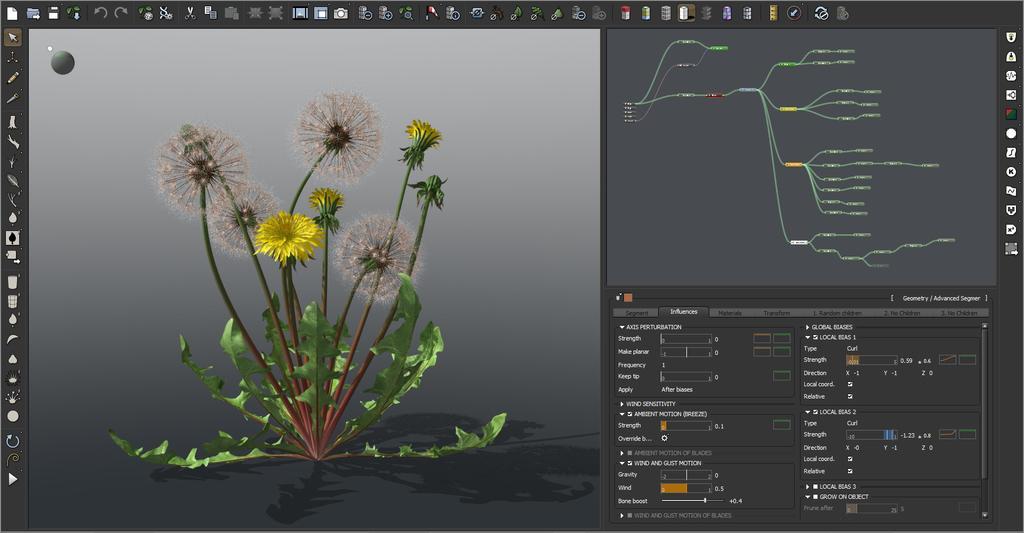In one or two sentences, can you explain what this image depicts? In this picture on the left side, it looks like a 3D image and on the right side there are many editing tools on the computer display. 